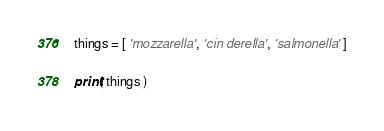Convert code to text. <code><loc_0><loc_0><loc_500><loc_500><_Python_>things = [ 'mozzarella', 'cin derella', 'salmonella' ]

print( things )</code> 